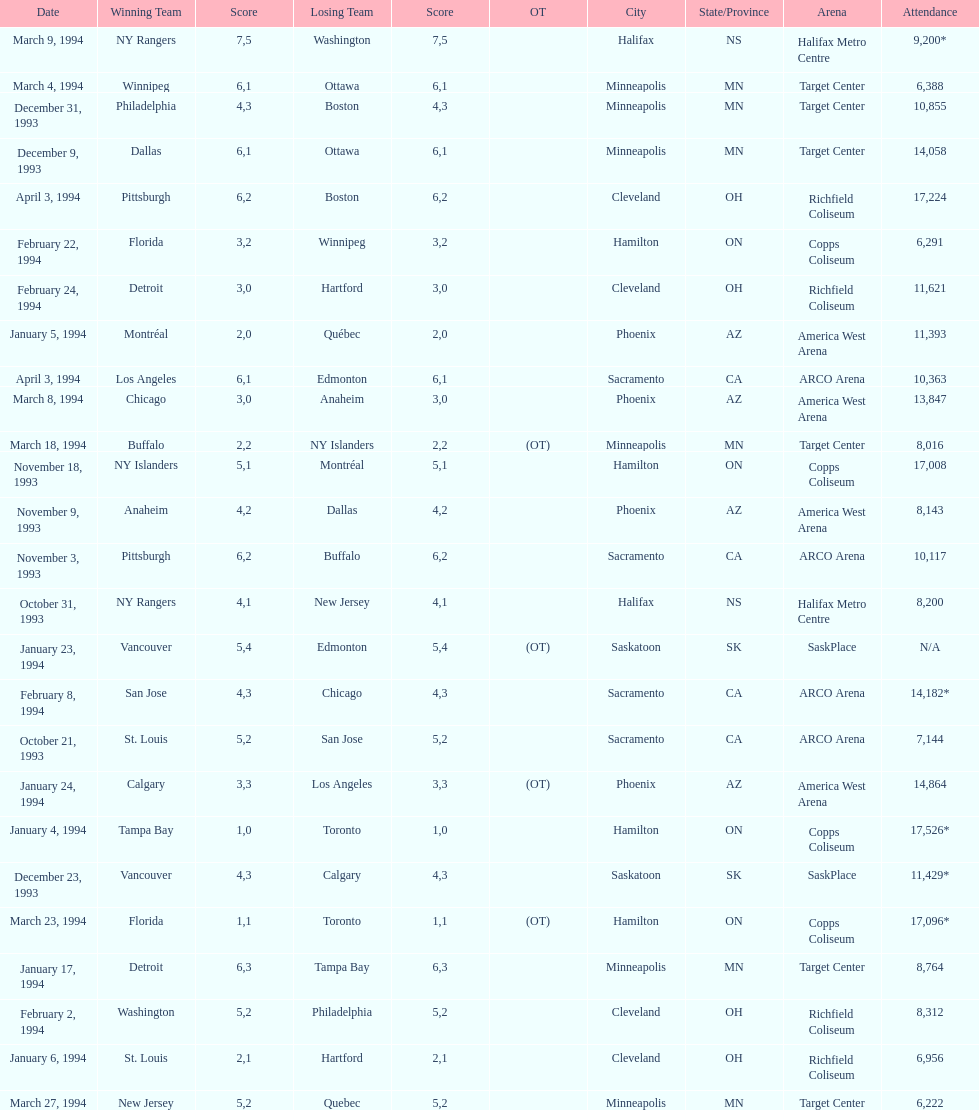How many neutral site games resulted in overtime (ot)? 4. 